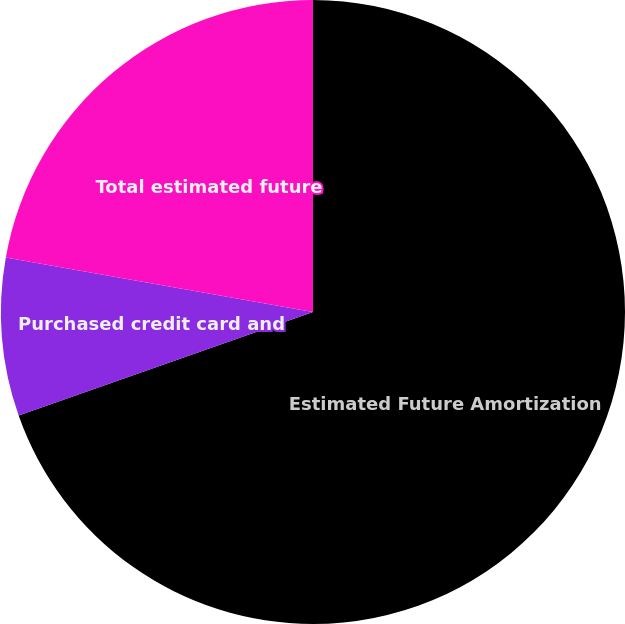Convert chart. <chart><loc_0><loc_0><loc_500><loc_500><pie_chart><fcel>Estimated Future Amortization<fcel>Purchased credit card and<fcel>Total estimated future<nl><fcel>69.62%<fcel>8.18%<fcel>22.2%<nl></chart> 